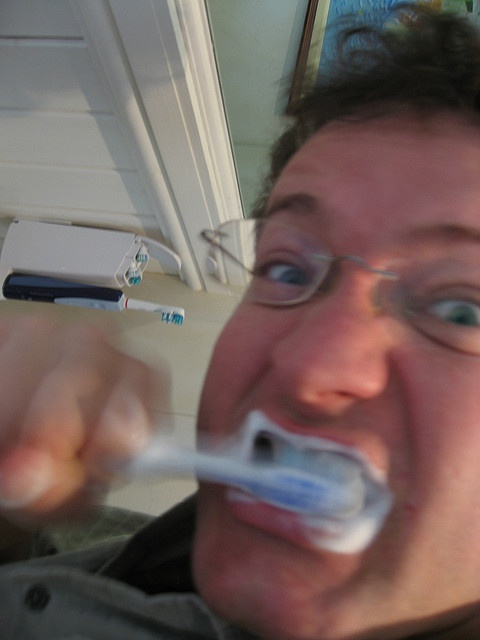Describe the objects in this image and their specific colors. I can see people in gray, brown, black, and maroon tones, toothbrush in gray and darkgray tones, and toothbrush in gray, black, darkgray, and navy tones in this image. 